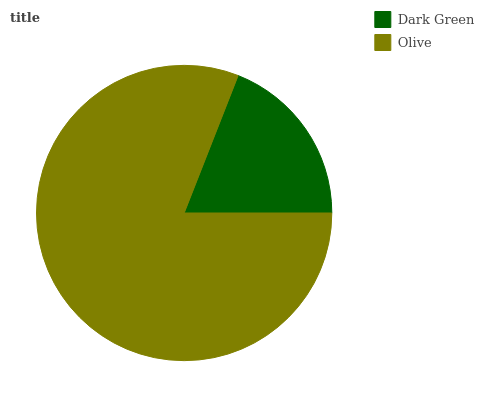Is Dark Green the minimum?
Answer yes or no. Yes. Is Olive the maximum?
Answer yes or no. Yes. Is Olive the minimum?
Answer yes or no. No. Is Olive greater than Dark Green?
Answer yes or no. Yes. Is Dark Green less than Olive?
Answer yes or no. Yes. Is Dark Green greater than Olive?
Answer yes or no. No. Is Olive less than Dark Green?
Answer yes or no. No. Is Olive the high median?
Answer yes or no. Yes. Is Dark Green the low median?
Answer yes or no. Yes. Is Dark Green the high median?
Answer yes or no. No. Is Olive the low median?
Answer yes or no. No. 